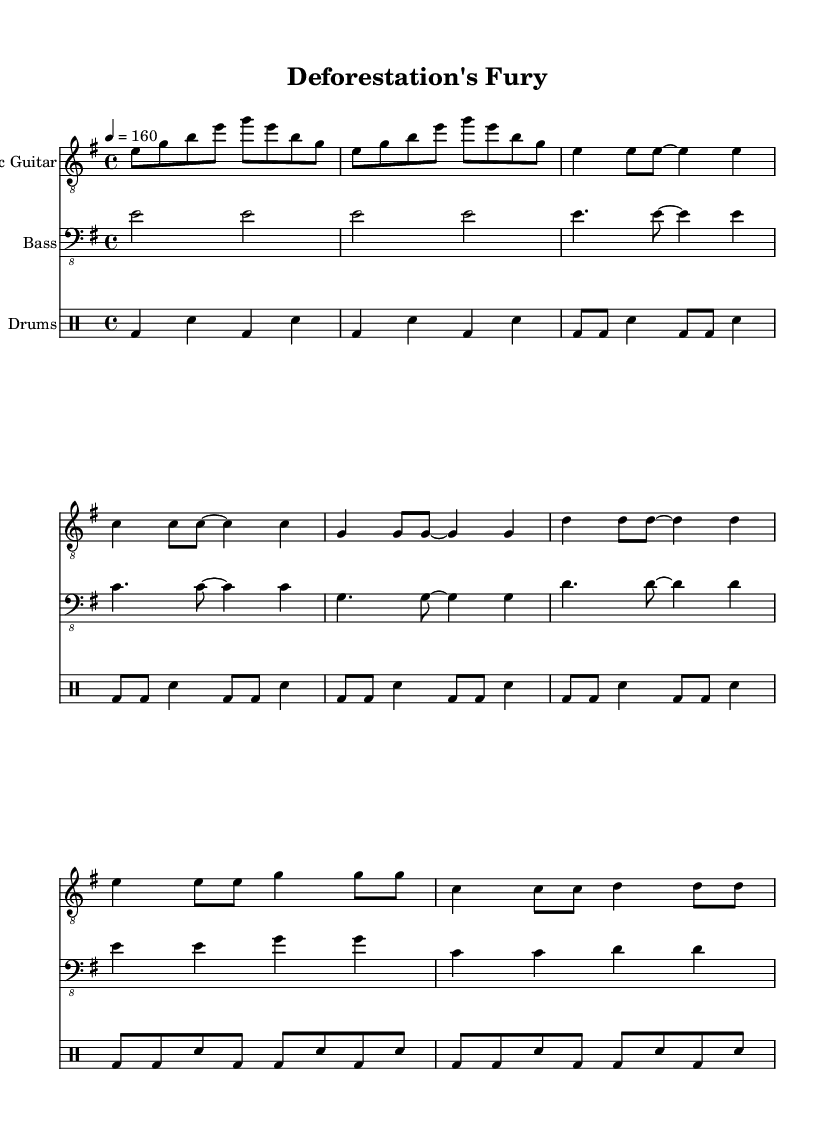What is the key signature of this music? The key signature indicates that the music is in E minor, which is represented by one sharp (F#) in the key signature.
Answer: E minor What is the time signature of this music? The time signature is indicated at the beginning of the staff, which shows that the music is written in 4/4 time, meaning there are four beats in each measure.
Answer: 4/4 What is the tempo marking of the piece? The tempo marking, located above the staff, indicates that the music should be played at a quarter note equals 160 beats per minute, reflecting a fast pace typical for metal music.
Answer: 160 How many measures are in the verse section? The verse section consists of four measures, as can be counted within the provided musical notation for that section.
Answer: 4 What instrument plays the main melodic line in this piece? The main melodic line is played by the electric guitar, which is specified in the score as the instrument providing the lead part for this metal piece.
Answer: Electric Guitar What rhythmic pattern is predominant in the drum part during the verse? The drum part during the verse features a consistent pattern of bass drums (bd) alternating with snare drums (sn), characterized by a driving rhythm typical of metal genres.
Answer: Bass and Snare pattern How does the chorus section differ from the verse in terms of dynamics? The chorus typically features a louder dynamic than the verse, supported by the markings and the energetic feel common in metal music, which often intensifies at this point to emphasize the main theme.
Answer: Louder 